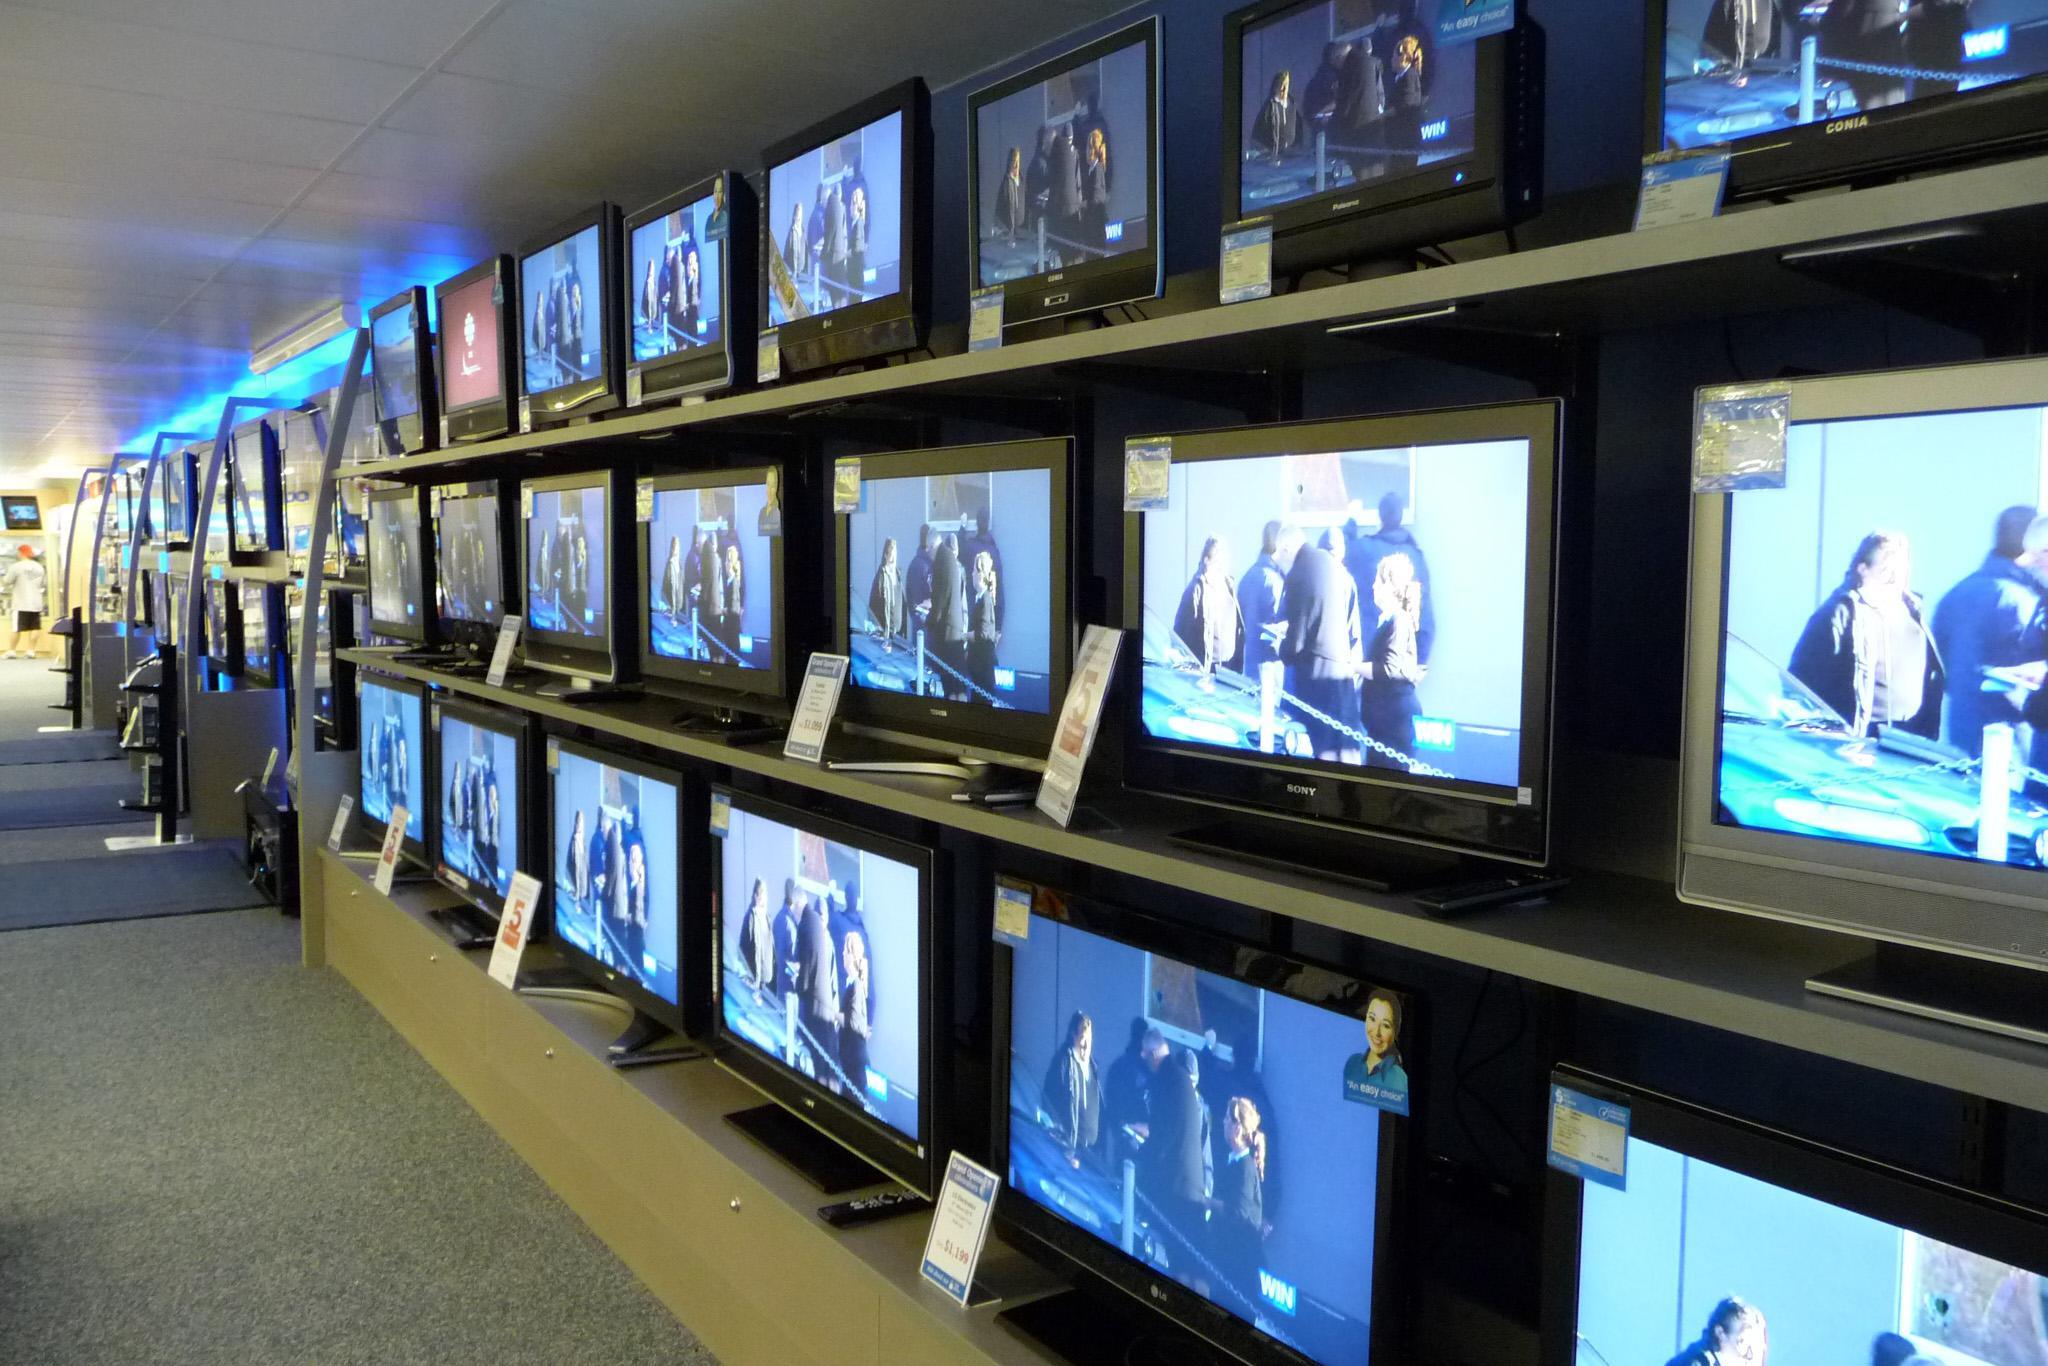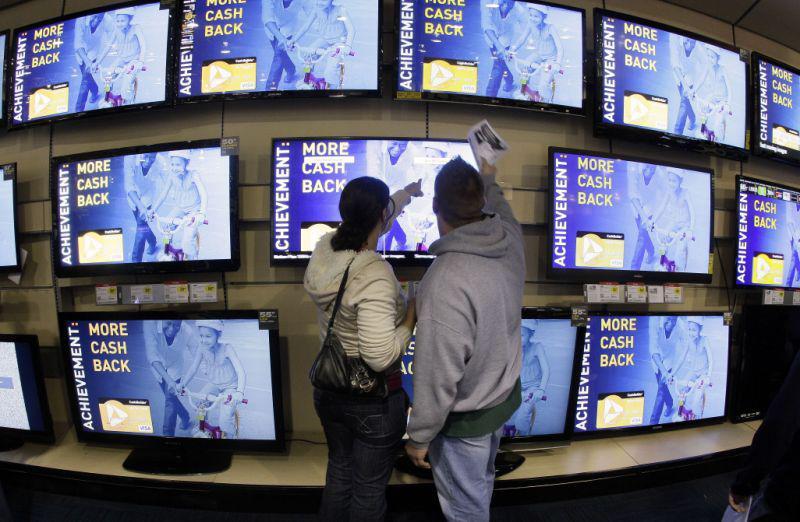The first image is the image on the left, the second image is the image on the right. For the images displayed, is the sentence "The right image contains two humans." factually correct? Answer yes or no. Yes. 